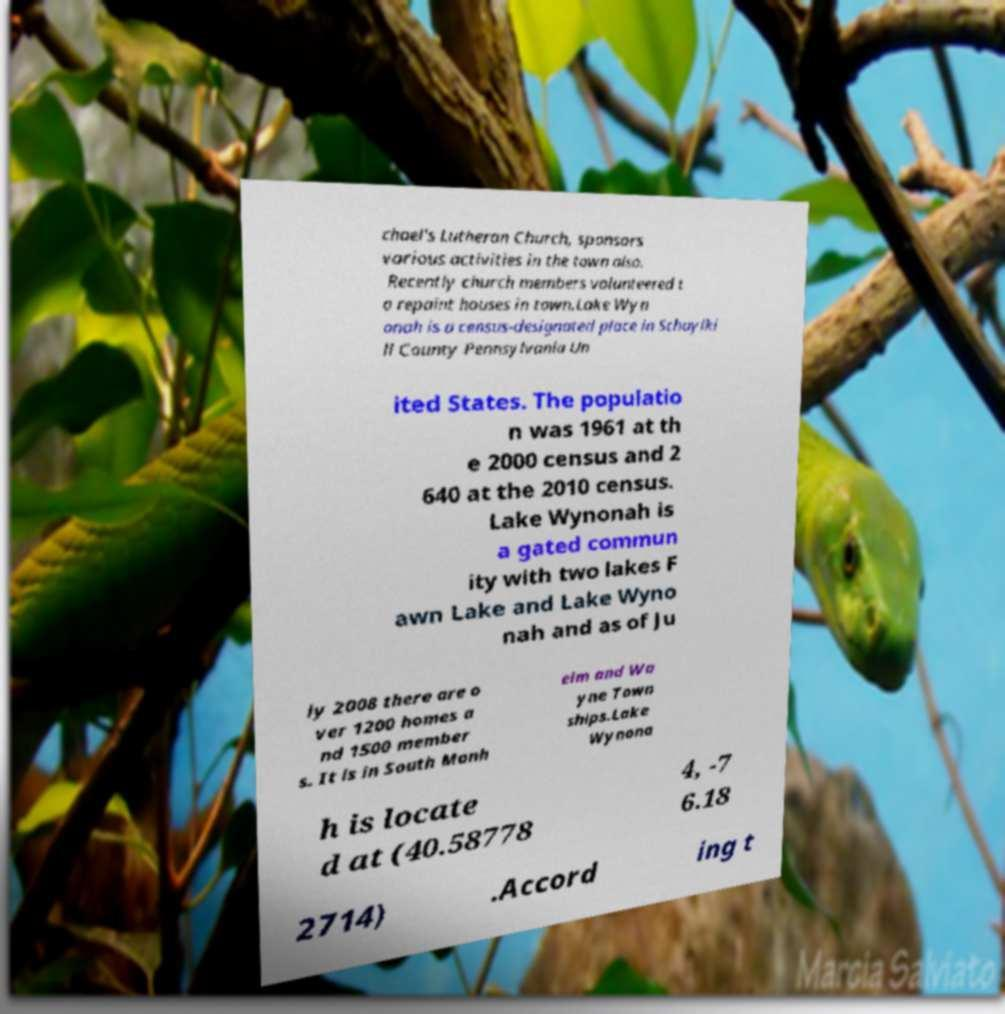Can you accurately transcribe the text from the provided image for me? chael's Lutheran Church, sponsors various activities in the town also. Recently church members volunteered t o repaint houses in town.Lake Wyn onah is a census-designated place in Schuylki ll County Pennsylvania Un ited States. The populatio n was 1961 at th e 2000 census and 2 640 at the 2010 census. Lake Wynonah is a gated commun ity with two lakes F awn Lake and Lake Wyno nah and as of Ju ly 2008 there are o ver 1200 homes a nd 1500 member s. It is in South Manh eim and Wa yne Town ships.Lake Wynona h is locate d at (40.58778 4, -7 6.18 2714) .Accord ing t 